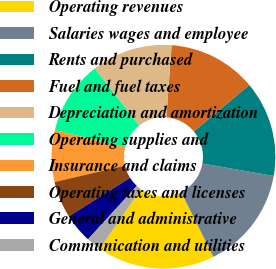Convert chart. <chart><loc_0><loc_0><loc_500><loc_500><pie_chart><fcel>Operating revenues<fcel>Salaries wages and employee<fcel>Rents and purchased<fcel>Fuel and fuel taxes<fcel>Depreciation and amortization<fcel>Operating supplies and<fcel>Insurance and claims<fcel>Operating taxes and licenses<fcel>General and administrative<fcel>Communication and utilities<nl><fcel>17.01%<fcel>14.89%<fcel>13.83%<fcel>12.76%<fcel>11.7%<fcel>10.64%<fcel>7.45%<fcel>5.32%<fcel>4.26%<fcel>2.14%<nl></chart> 